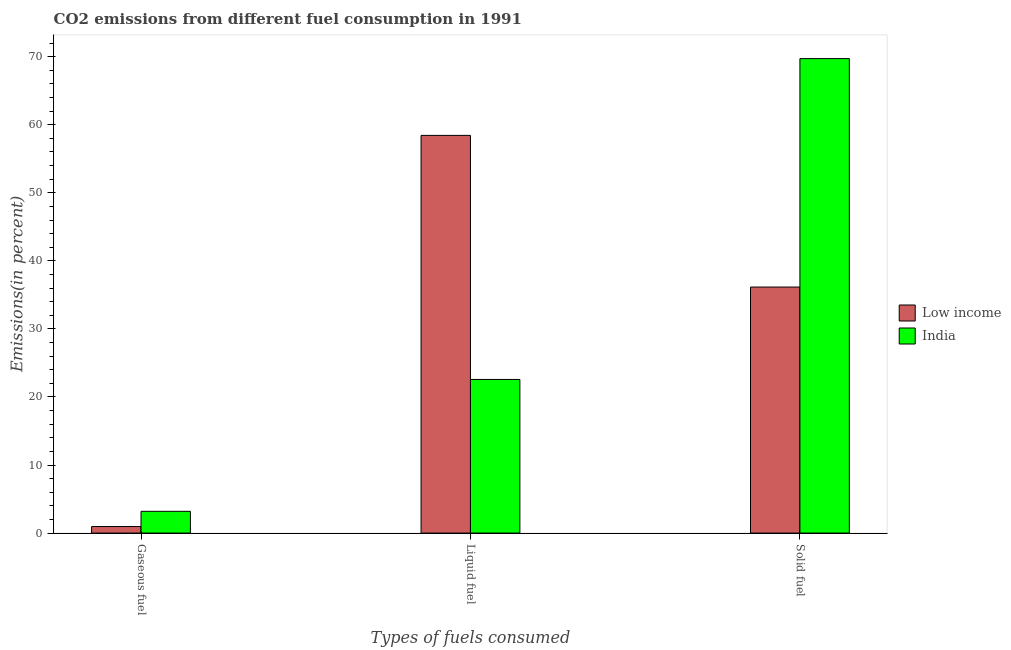How many different coloured bars are there?
Your answer should be very brief. 2. How many groups of bars are there?
Offer a terse response. 3. Are the number of bars per tick equal to the number of legend labels?
Offer a very short reply. Yes. Are the number of bars on each tick of the X-axis equal?
Make the answer very short. Yes. How many bars are there on the 1st tick from the right?
Make the answer very short. 2. What is the label of the 1st group of bars from the left?
Provide a succinct answer. Gaseous fuel. What is the percentage of solid fuel emission in Low income?
Your answer should be very brief. 36.15. Across all countries, what is the maximum percentage of gaseous fuel emission?
Ensure brevity in your answer.  3.2. Across all countries, what is the minimum percentage of gaseous fuel emission?
Ensure brevity in your answer.  0.96. In which country was the percentage of solid fuel emission maximum?
Keep it short and to the point. India. In which country was the percentage of liquid fuel emission minimum?
Your answer should be very brief. India. What is the total percentage of solid fuel emission in the graph?
Provide a short and direct response. 105.87. What is the difference between the percentage of gaseous fuel emission in Low income and that in India?
Provide a succinct answer. -2.24. What is the difference between the percentage of solid fuel emission in Low income and the percentage of liquid fuel emission in India?
Offer a terse response. 13.58. What is the average percentage of gaseous fuel emission per country?
Your answer should be compact. 2.08. What is the difference between the percentage of liquid fuel emission and percentage of gaseous fuel emission in India?
Provide a short and direct response. 19.38. What is the ratio of the percentage of gaseous fuel emission in India to that in Low income?
Offer a terse response. 3.33. Is the percentage of gaseous fuel emission in Low income less than that in India?
Offer a very short reply. Yes. Is the difference between the percentage of liquid fuel emission in India and Low income greater than the difference between the percentage of solid fuel emission in India and Low income?
Provide a short and direct response. No. What is the difference between the highest and the second highest percentage of liquid fuel emission?
Your answer should be compact. 35.86. What is the difference between the highest and the lowest percentage of solid fuel emission?
Offer a very short reply. 33.57. In how many countries, is the percentage of solid fuel emission greater than the average percentage of solid fuel emission taken over all countries?
Your response must be concise. 1. What does the 1st bar from the left in Solid fuel represents?
Your answer should be very brief. Low income. Is it the case that in every country, the sum of the percentage of gaseous fuel emission and percentage of liquid fuel emission is greater than the percentage of solid fuel emission?
Keep it short and to the point. No. How many bars are there?
Provide a short and direct response. 6. How many countries are there in the graph?
Provide a succinct answer. 2. Are the values on the major ticks of Y-axis written in scientific E-notation?
Your answer should be very brief. No. Does the graph contain any zero values?
Your answer should be very brief. No. How many legend labels are there?
Provide a succinct answer. 2. What is the title of the graph?
Offer a terse response. CO2 emissions from different fuel consumption in 1991. What is the label or title of the X-axis?
Give a very brief answer. Types of fuels consumed. What is the label or title of the Y-axis?
Make the answer very short. Emissions(in percent). What is the Emissions(in percent) of Low income in Gaseous fuel?
Provide a short and direct response. 0.96. What is the Emissions(in percent) of India in Gaseous fuel?
Your answer should be compact. 3.2. What is the Emissions(in percent) of Low income in Liquid fuel?
Your answer should be very brief. 58.44. What is the Emissions(in percent) of India in Liquid fuel?
Keep it short and to the point. 22.57. What is the Emissions(in percent) of Low income in Solid fuel?
Make the answer very short. 36.15. What is the Emissions(in percent) in India in Solid fuel?
Make the answer very short. 69.72. Across all Types of fuels consumed, what is the maximum Emissions(in percent) in Low income?
Your answer should be very brief. 58.44. Across all Types of fuels consumed, what is the maximum Emissions(in percent) of India?
Your answer should be very brief. 69.72. Across all Types of fuels consumed, what is the minimum Emissions(in percent) of Low income?
Your answer should be very brief. 0.96. Across all Types of fuels consumed, what is the minimum Emissions(in percent) of India?
Your response must be concise. 3.2. What is the total Emissions(in percent) in Low income in the graph?
Your answer should be very brief. 95.55. What is the total Emissions(in percent) of India in the graph?
Offer a very short reply. 95.49. What is the difference between the Emissions(in percent) in Low income in Gaseous fuel and that in Liquid fuel?
Your answer should be very brief. -57.48. What is the difference between the Emissions(in percent) in India in Gaseous fuel and that in Liquid fuel?
Offer a very short reply. -19.38. What is the difference between the Emissions(in percent) of Low income in Gaseous fuel and that in Solid fuel?
Offer a terse response. -35.19. What is the difference between the Emissions(in percent) of India in Gaseous fuel and that in Solid fuel?
Provide a short and direct response. -66.52. What is the difference between the Emissions(in percent) in Low income in Liquid fuel and that in Solid fuel?
Give a very brief answer. 22.29. What is the difference between the Emissions(in percent) of India in Liquid fuel and that in Solid fuel?
Your answer should be compact. -47.15. What is the difference between the Emissions(in percent) of Low income in Gaseous fuel and the Emissions(in percent) of India in Liquid fuel?
Give a very brief answer. -21.61. What is the difference between the Emissions(in percent) in Low income in Gaseous fuel and the Emissions(in percent) in India in Solid fuel?
Offer a terse response. -68.76. What is the difference between the Emissions(in percent) in Low income in Liquid fuel and the Emissions(in percent) in India in Solid fuel?
Provide a short and direct response. -11.28. What is the average Emissions(in percent) of Low income per Types of fuels consumed?
Make the answer very short. 31.85. What is the average Emissions(in percent) in India per Types of fuels consumed?
Offer a terse response. 31.83. What is the difference between the Emissions(in percent) of Low income and Emissions(in percent) of India in Gaseous fuel?
Make the answer very short. -2.24. What is the difference between the Emissions(in percent) in Low income and Emissions(in percent) in India in Liquid fuel?
Provide a succinct answer. 35.86. What is the difference between the Emissions(in percent) of Low income and Emissions(in percent) of India in Solid fuel?
Keep it short and to the point. -33.57. What is the ratio of the Emissions(in percent) in Low income in Gaseous fuel to that in Liquid fuel?
Your answer should be compact. 0.02. What is the ratio of the Emissions(in percent) of India in Gaseous fuel to that in Liquid fuel?
Provide a short and direct response. 0.14. What is the ratio of the Emissions(in percent) in Low income in Gaseous fuel to that in Solid fuel?
Give a very brief answer. 0.03. What is the ratio of the Emissions(in percent) in India in Gaseous fuel to that in Solid fuel?
Offer a terse response. 0.05. What is the ratio of the Emissions(in percent) in Low income in Liquid fuel to that in Solid fuel?
Your answer should be compact. 1.62. What is the ratio of the Emissions(in percent) in India in Liquid fuel to that in Solid fuel?
Your response must be concise. 0.32. What is the difference between the highest and the second highest Emissions(in percent) in Low income?
Make the answer very short. 22.29. What is the difference between the highest and the second highest Emissions(in percent) in India?
Ensure brevity in your answer.  47.15. What is the difference between the highest and the lowest Emissions(in percent) in Low income?
Give a very brief answer. 57.48. What is the difference between the highest and the lowest Emissions(in percent) in India?
Your answer should be very brief. 66.52. 